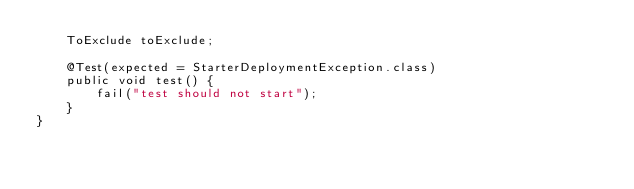Convert code to text. <code><loc_0><loc_0><loc_500><loc_500><_Java_>    ToExclude toExclude;

    @Test(expected = StarterDeploymentException.class)
    public void test() {
        fail("test should not start");
    }
}
</code> 